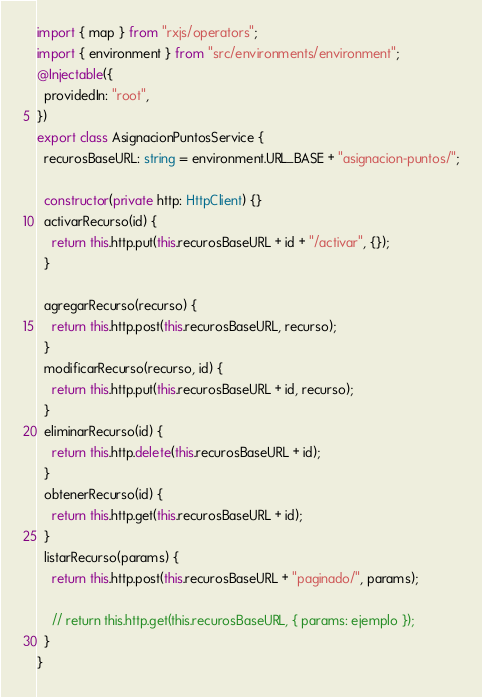<code> <loc_0><loc_0><loc_500><loc_500><_TypeScript_>import { map } from "rxjs/operators";
import { environment } from "src/environments/environment";
@Injectable({
  providedIn: "root",
})
export class AsignacionPuntosService {
  recurosBaseURL: string = environment.URL_BASE + "asignacion-puntos/";

  constructor(private http: HttpClient) {}
  activarRecurso(id) {
    return this.http.put(this.recurosBaseURL + id + "/activar", {});
  }

  agregarRecurso(recurso) {
    return this.http.post(this.recurosBaseURL, recurso);
  }
  modificarRecurso(recurso, id) {
    return this.http.put(this.recurosBaseURL + id, recurso);
  }
  eliminarRecurso(id) {
    return this.http.delete(this.recurosBaseURL + id);
  }
  obtenerRecurso(id) {
    return this.http.get(this.recurosBaseURL + id);
  }
  listarRecurso(params) {
    return this.http.post(this.recurosBaseURL + "paginado/", params);

    // return this.http.get(this.recurosBaseURL, { params: ejemplo });
  }
}
</code> 